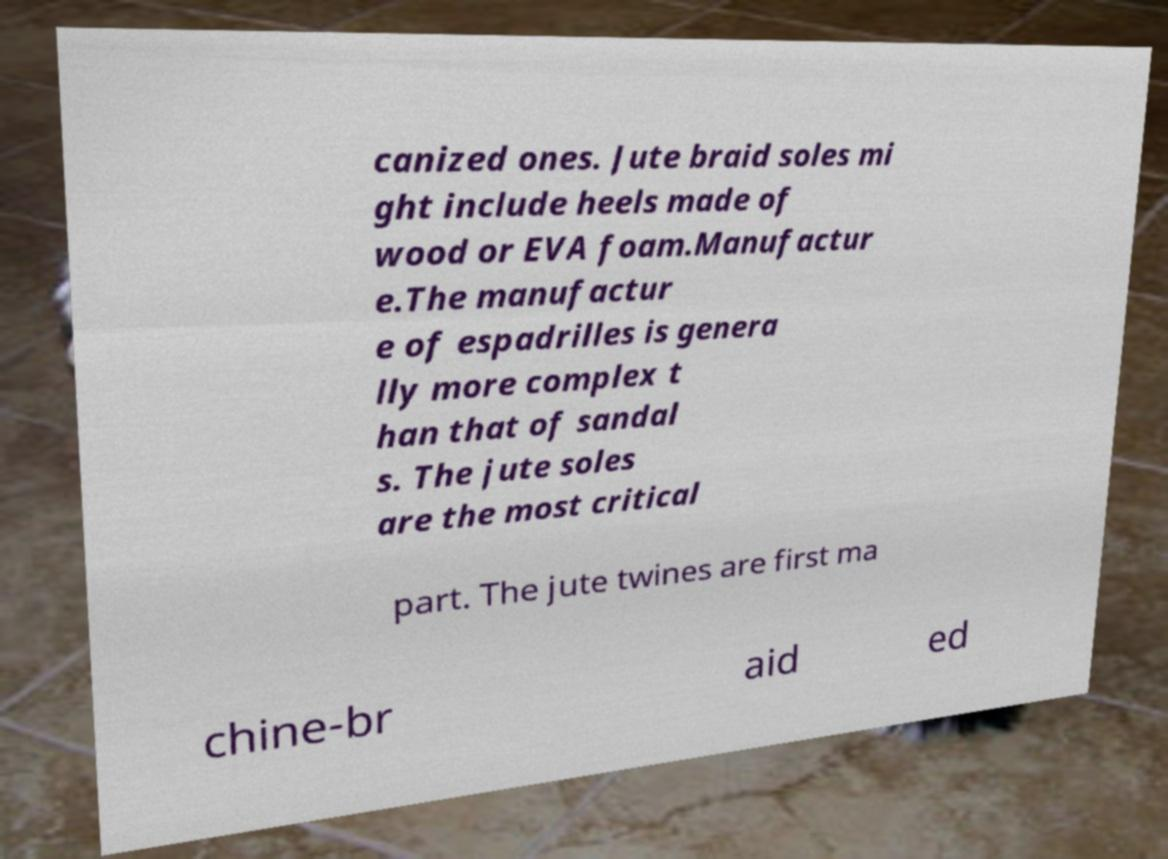I need the written content from this picture converted into text. Can you do that? canized ones. Jute braid soles mi ght include heels made of wood or EVA foam.Manufactur e.The manufactur e of espadrilles is genera lly more complex t han that of sandal s. The jute soles are the most critical part. The jute twines are first ma chine-br aid ed 